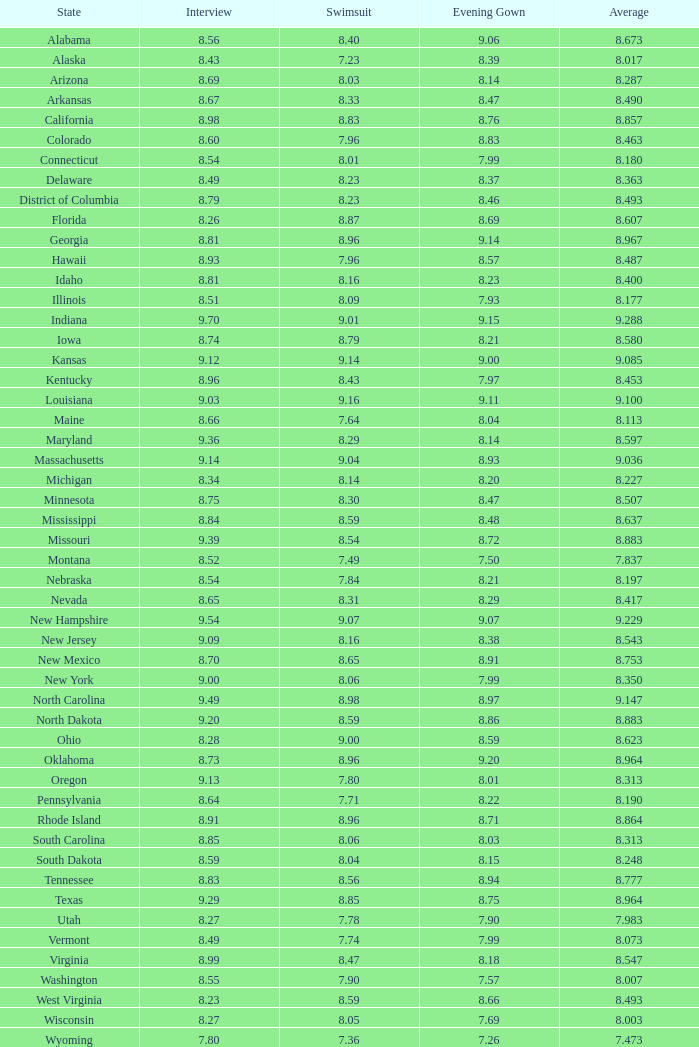Determine the total quantity of swimsuits when evening gowns have a rating under 8.21, an average score of 8.453, and an interview score below 9.09. 1.0. 